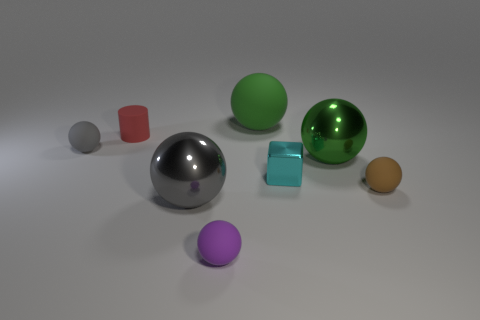Are the objects arranged in a specific pattern or order? The objects in the image don't seem to follow a strict pattern; they are scattered randomly across a flat surface. The arrangement seems casual without any discernible sequence, possibly to showcase the different sizes and colors of the objects. Could the arrangement signify anything conceptually? Conceptually, the arrangement could represent diversity or variety, as it includes objects of various colors and reflective qualities. It might also suggest the idea of random distribution, where objects are placed without a predefined order, akin to natural occurrences. 